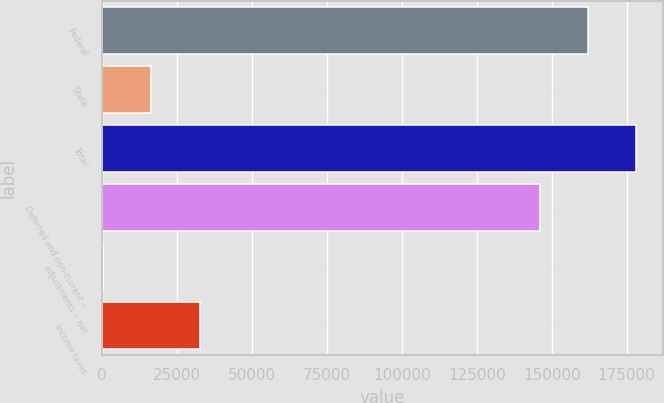Convert chart. <chart><loc_0><loc_0><loc_500><loc_500><bar_chart><fcel>Federal<fcel>State<fcel>Total<fcel>Deferred and non-current --<fcel>adjustments -- net<fcel>Income taxes<nl><fcel>162114<fcel>16455.7<fcel>178246<fcel>145981<fcel>323<fcel>32588.4<nl></chart> 